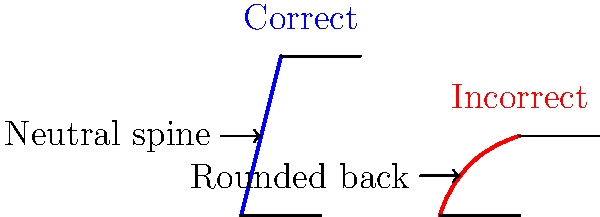During desk exercises, which spinal alignment is correct for maintaining proper posture, and why is it important for overall health and performance? 1. Spinal alignment during desk exercises:
   - Correct alignment: Neutral spine (left image)
   - Incorrect alignment: Rounded back (right image)

2. Importance of correct spinal alignment:
   a) Reduces stress on spinal structures
   b) Minimizes risk of back pain and injuries
   c) Improves breathing and core engagement
   d) Enhances overall posture and body awareness

3. Characteristics of neutral spine position:
   - Natural S-curve of the spine is maintained
   - Head is aligned over shoulders
   - Shoulders are relaxed and pulled back slightly
   - Lower back has a slight inward curve (lordosis)

4. Consequences of incorrect (rounded back) posture:
   - Increased pressure on intervertebral discs
   - Muscle imbalances and tension
   - Reduced core activation
   - Potential for long-term postural issues

5. Applying correct posture to desk exercises:
   - Maintain awareness of spinal position throughout movements
   - Engage core muscles to support neutral spine
   - Use visual cues or mirrors to check alignment
   - Incorporate exercises that promote proper posture (e.g., rows, chest openers)

6. Long-term benefits for athletes:
   - Improved performance in sports-specific movements
   - Reduced risk of overuse injuries
   - Enhanced body control and proprioception
   - Better transfer of power through the kinetic chain
Answer: Neutral spine alignment (left image) is correct, as it maintains the natural S-curve of the spine, reducing stress on spinal structures and improving overall health and performance. 